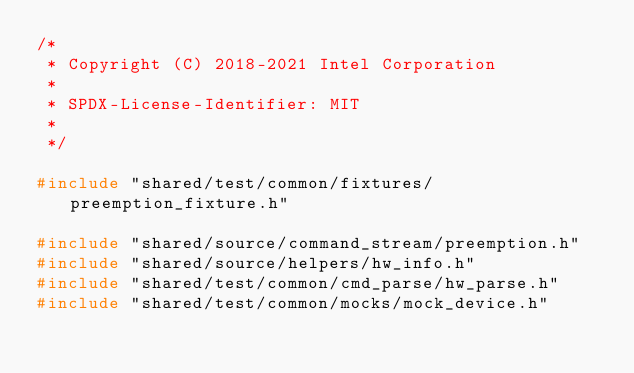Convert code to text. <code><loc_0><loc_0><loc_500><loc_500><_C++_>/*
 * Copyright (C) 2018-2021 Intel Corporation
 *
 * SPDX-License-Identifier: MIT
 *
 */

#include "shared/test/common/fixtures/preemption_fixture.h"

#include "shared/source/command_stream/preemption.h"
#include "shared/source/helpers/hw_info.h"
#include "shared/test/common/cmd_parse/hw_parse.h"
#include "shared/test/common/mocks/mock_device.h"
</code> 